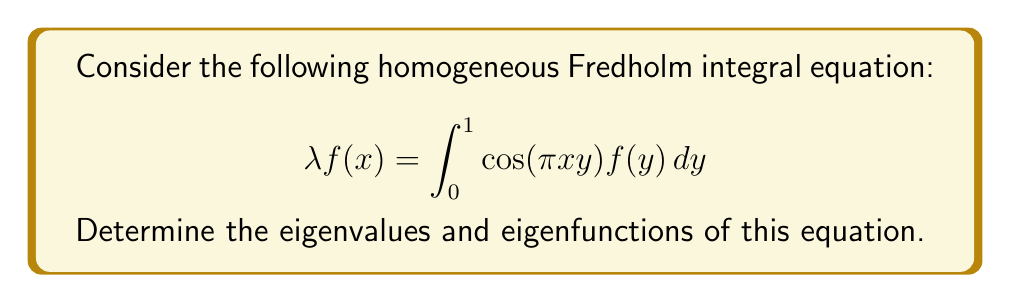Teach me how to tackle this problem. To solve this problem, we'll follow these steps:

1) First, we need to recognize that this is a separable kernel. We can write the kernel as:

   $$K(x,y) = \cos(\pi x y) = \cos(\pi x) \cos(\pi y)$$

2) For a separable kernel, we can assume the eigenfunction has the form:

   $$f(x) = A \cos(\pi x)$$

   where A is a constant.

3) Substituting this into the original equation:

   $$\lambda A \cos(\pi x) = \int_0^1 \cos(\pi x y) A \cos(\pi y) dy$$

4) Simplifying the right-hand side:

   $$\lambda A \cos(\pi x) = A \cos(\pi x) \int_0^1 \cos^2(\pi y) dy$$

5) Evaluate the integral:

   $$\int_0^1 \cos^2(\pi y) dy = \frac{1}{2}$$

6) Our equation now becomes:

   $$\lambda A \cos(\pi x) = \frac{1}{2} A \cos(\pi x)$$

7) For this to be true for all x, we must have:

   $$\lambda = \frac{1}{2}$$

8) Therefore, the only eigenvalue is $\frac{1}{2}$, and the corresponding eigenfunction is:

   $$f(x) = A \cos(\pi x)$$

   where A is any non-zero constant.
Answer: Eigenvalue: $\lambda = \frac{1}{2}$
Eigenfunction: $f(x) = A \cos(\pi x)$, where A is a non-zero constant 